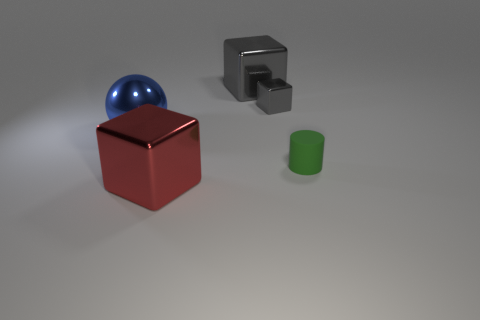Add 3 gray objects. How many objects exist? 8 Subtract all spheres. How many objects are left? 4 Subtract all tiny green matte objects. Subtract all gray shiny cubes. How many objects are left? 2 Add 3 big blue shiny spheres. How many big blue shiny spheres are left? 4 Add 1 small blue cylinders. How many small blue cylinders exist? 1 Subtract 0 brown spheres. How many objects are left? 5 